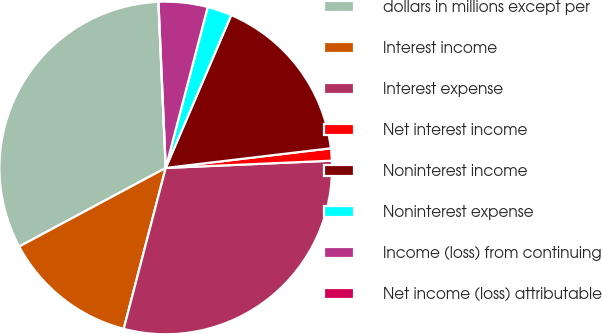<chart> <loc_0><loc_0><loc_500><loc_500><pie_chart><fcel>dollars in millions except per<fcel>Interest income<fcel>Interest expense<fcel>Net interest income<fcel>Noninterest income<fcel>Noninterest expense<fcel>Income (loss) from continuing<fcel>Net income (loss) attributable<nl><fcel>32.14%<fcel>13.1%<fcel>29.76%<fcel>1.19%<fcel>16.67%<fcel>2.38%<fcel>4.76%<fcel>0.0%<nl></chart> 